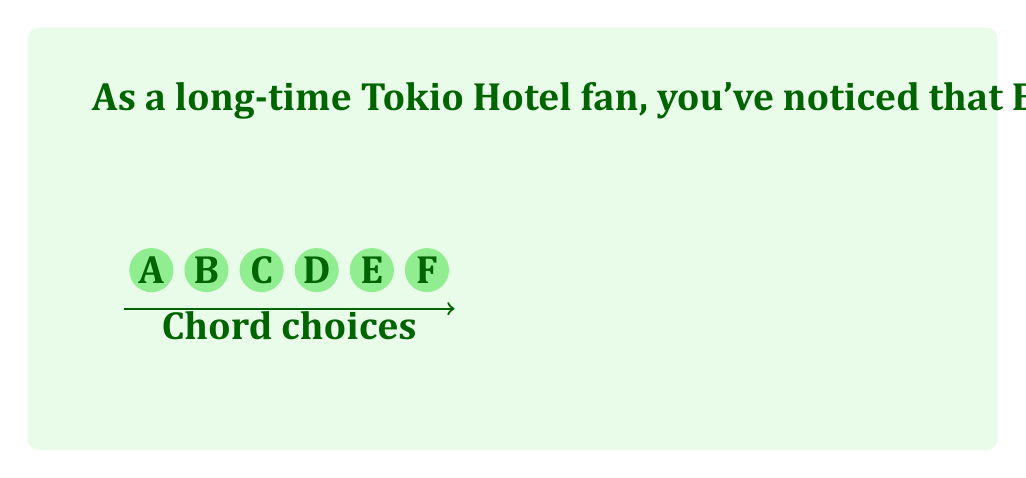Can you answer this question? Let's approach this step-by-step:

1) This is a problem of permutation with repetition. We are selecting 4 chords out of 6, where:
   - The order matters (ABCD is different from DCBA)
   - Repetition is allowed (we can use the same chord multiple times)

2) In such cases, we use the formula:
   $$n^r$$
   where $n$ is the number of choices for each position, and $r$ is the number of positions to fill.

3) In this problem:
   - $n = 6$ (we have 6 chords to choose from for each position)
   - $r = 4$ (we are creating a 4-chord progression)

4) Plugging these values into our formula:
   $$6^4$$

5) Calculating this:
   $$6^4 = 6 \times 6 \times 6 \times 6 = 1296$$

Therefore, Bill can create 1296 unique 4-chord progressions using these 6 chords.
Answer: 1296 